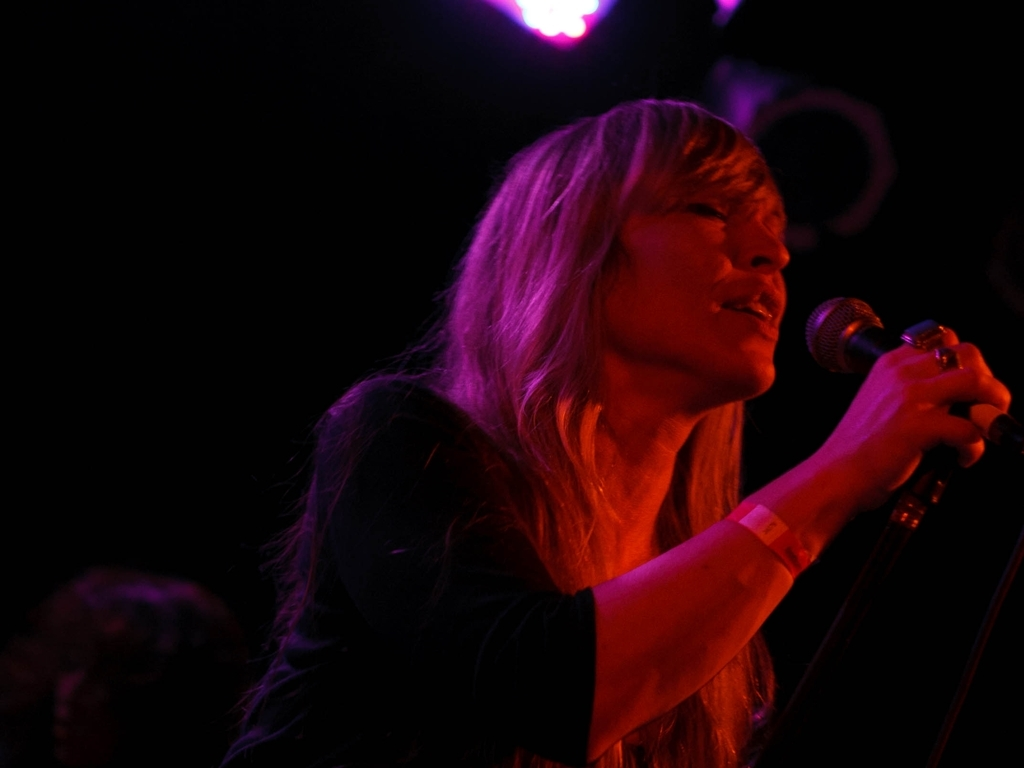Describe the atmosphere of the venue based on the image. The venue has a dimly lit, intimate atmosphere, accentuated by the spotlight on the performer. The limited visibility in the background suggests a focus on the artist, which is often characteristic of small to medium live music settings where the audience's attention is drawn to the emotional performance. 